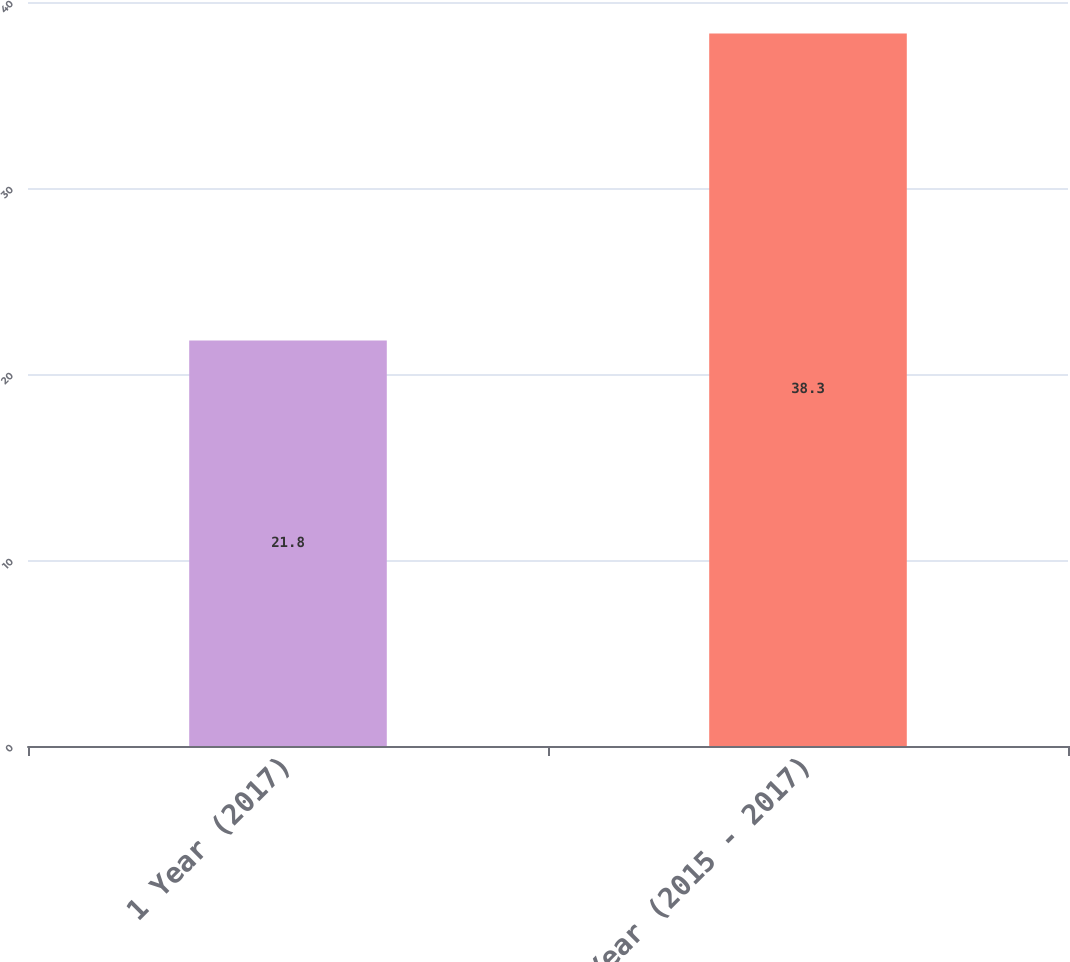Convert chart to OTSL. <chart><loc_0><loc_0><loc_500><loc_500><bar_chart><fcel>1 Year (2017)<fcel>3 Year (2015 - 2017)<nl><fcel>21.8<fcel>38.3<nl></chart> 